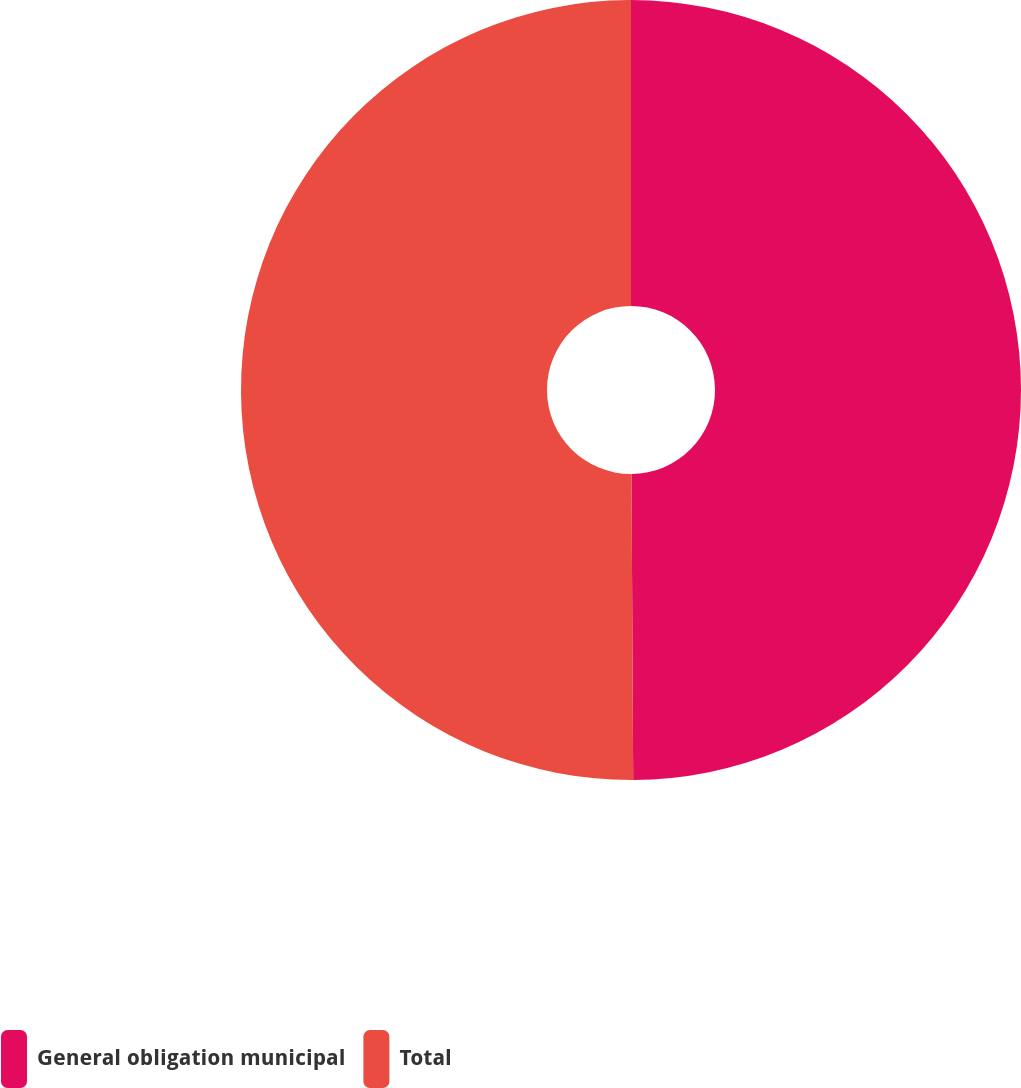Convert chart to OTSL. <chart><loc_0><loc_0><loc_500><loc_500><pie_chart><fcel>General obligation municipal<fcel>Total<nl><fcel>49.91%<fcel>50.09%<nl></chart> 